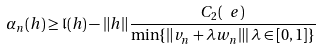Convert formula to latex. <formula><loc_0><loc_0><loc_500><loc_500>\alpha _ { n } ( h ) \geq \mathfrak { l } ( h ) - \| h \| \frac { C _ { 2 } ( \ e ) } { \min \{ \| v _ { n } + \lambda w _ { n } \| | \, \lambda \in [ 0 , 1 ] \} }</formula> 